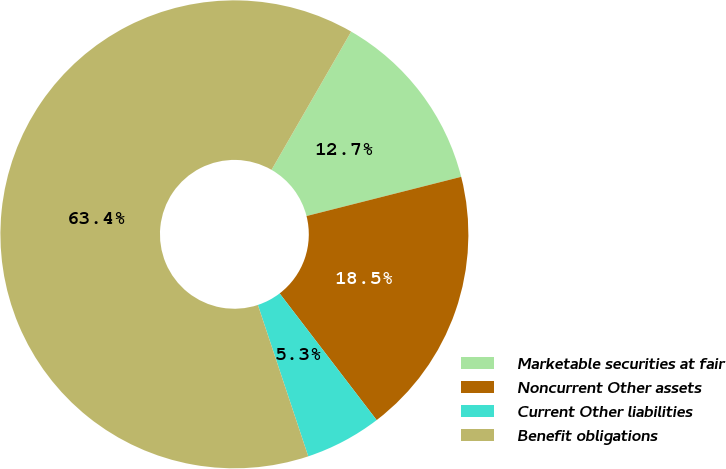Convert chart. <chart><loc_0><loc_0><loc_500><loc_500><pie_chart><fcel>Marketable securities at fair<fcel>Noncurrent Other assets<fcel>Current Other liabilities<fcel>Benefit obligations<nl><fcel>12.73%<fcel>18.55%<fcel>5.29%<fcel>63.43%<nl></chart> 